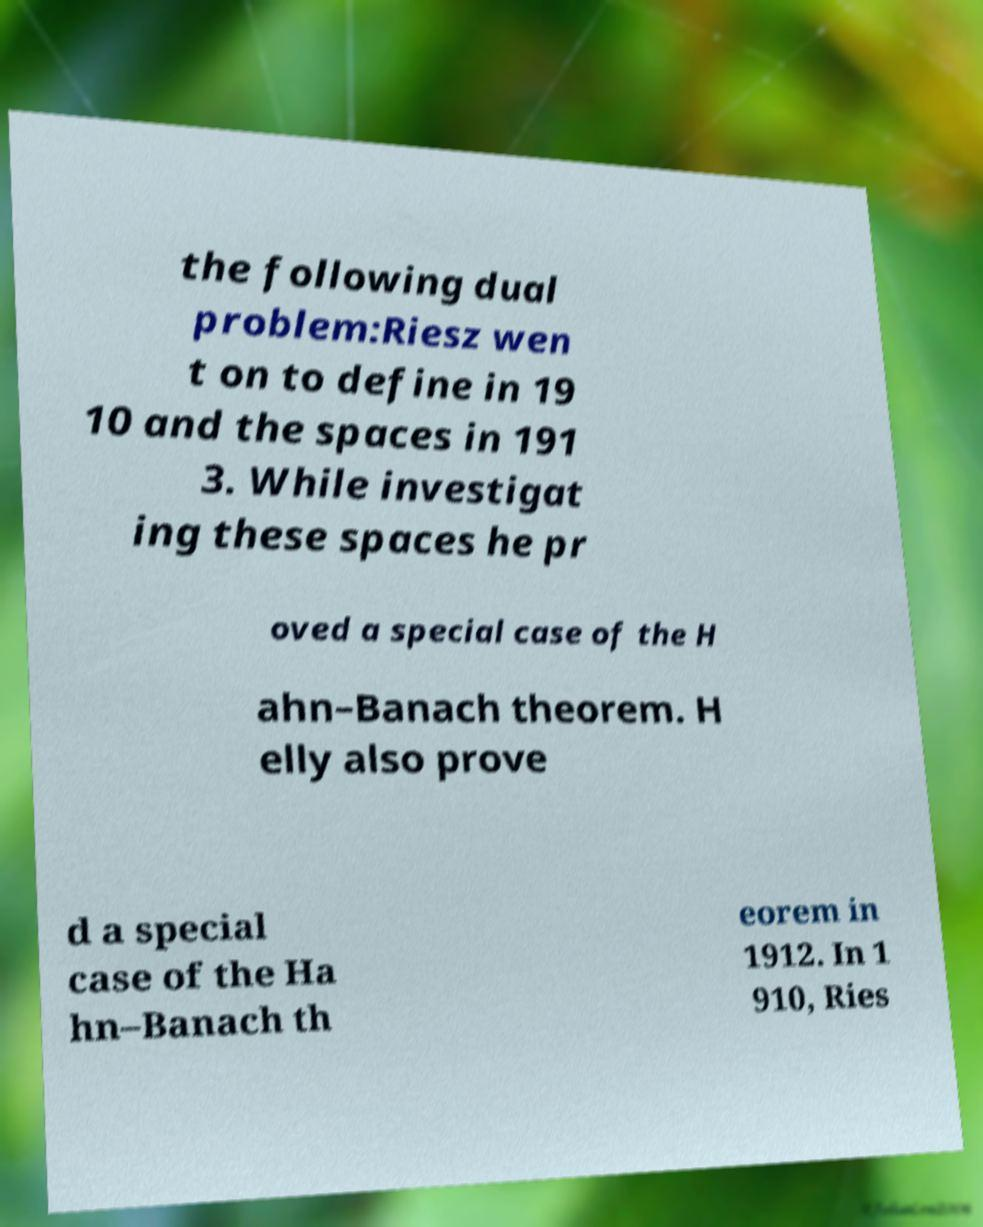Can you read and provide the text displayed in the image?This photo seems to have some interesting text. Can you extract and type it out for me? the following dual problem:Riesz wen t on to define in 19 10 and the spaces in 191 3. While investigat ing these spaces he pr oved a special case of the H ahn–Banach theorem. H elly also prove d a special case of the Ha hn–Banach th eorem in 1912. In 1 910, Ries 